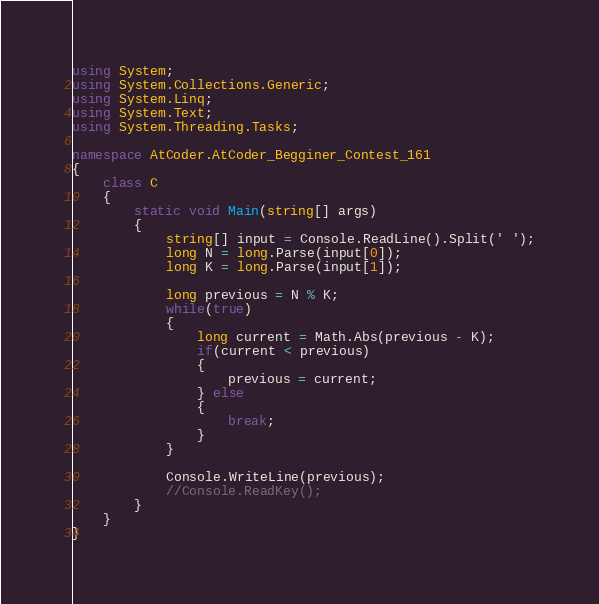<code> <loc_0><loc_0><loc_500><loc_500><_C#_>using System;
using System.Collections.Generic;
using System.Linq;
using System.Text;
using System.Threading.Tasks;

namespace AtCoder.AtCoder_Begginer_Contest_161
{
    class C
    {
        static void Main(string[] args)
        {
            string[] input = Console.ReadLine().Split(' ');
            long N = long.Parse(input[0]);
            long K = long.Parse(input[1]);

            long previous = N % K;
            while(true)
            {
                long current = Math.Abs(previous - K);
                if(current < previous)
                {
                    previous = current;
                } else
                {
                    break;
                }
            }

            Console.WriteLine(previous);
            //Console.ReadKey();
        }
    }
}
</code> 